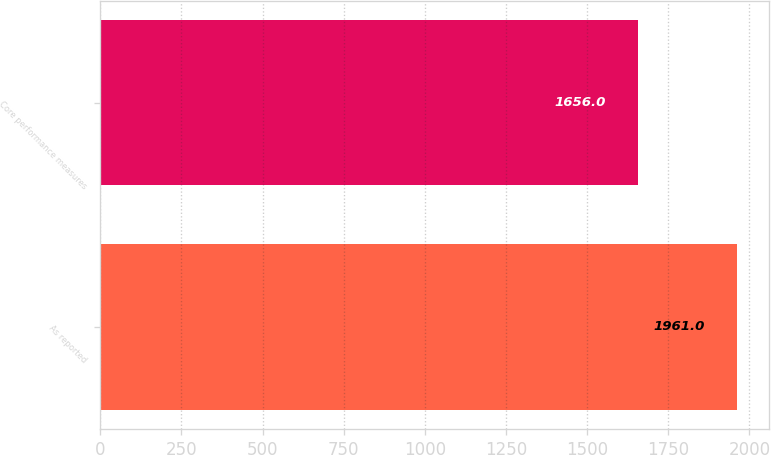<chart> <loc_0><loc_0><loc_500><loc_500><bar_chart><fcel>As reported<fcel>Core performance measures<nl><fcel>1961<fcel>1656<nl></chart> 